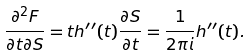Convert formula to latex. <formula><loc_0><loc_0><loc_500><loc_500>\frac { \partial ^ { 2 } F } { \partial t \partial S } = t h ^ { \prime \prime } ( t ) \frac { \partial S } { \partial t } = \frac { 1 } { 2 \pi i } h ^ { \prime \prime } ( t ) .</formula> 